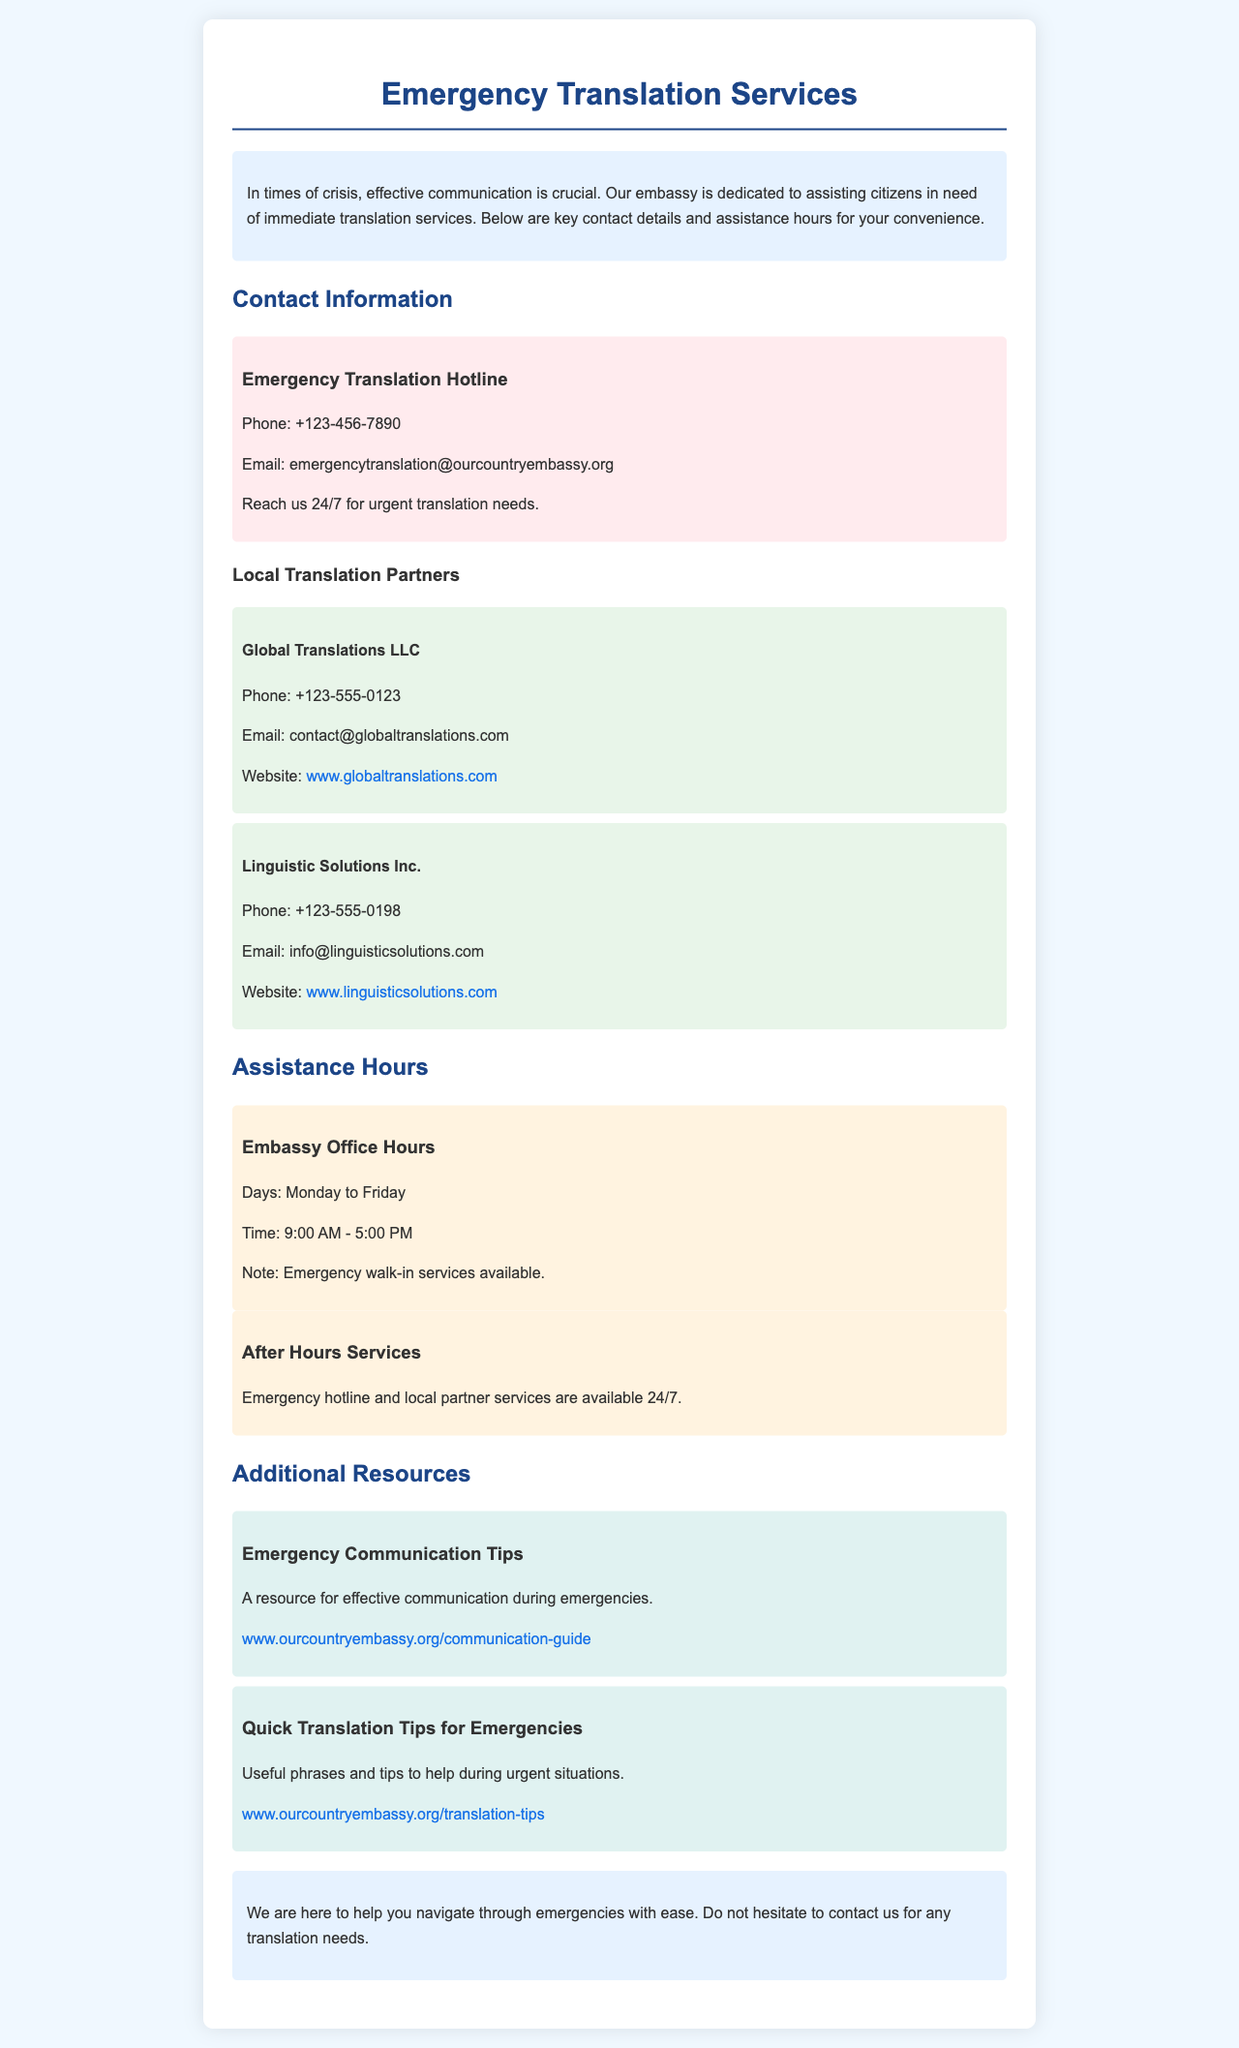What is the phone number for the Emergency Translation Hotline? The document provides the phone number for the hotline in the Contact Information section.
Answer: +123-456-7890 What are the embassy office hours? The document specifies the days and times for embassy office hours under Assistance Hours.
Answer: Monday to Friday, 9:00 AM - 5:00 PM How can I reach Global Translations LLC? The document includes contact details for Global Translations LLC in the Local Translation Partners section.
Answer: Phone: +123-555-0123, Email: contact@globaltranslations.com When are after-hours services available? The document mentions the availability of services after regular hours under Assistance Hours.
Answer: 24/7 What is the title of the resource that offers emergency communication tips? The title is found in the Additional Resources section and provides key information about effective communication.
Answer: Emergency Communication Tips 